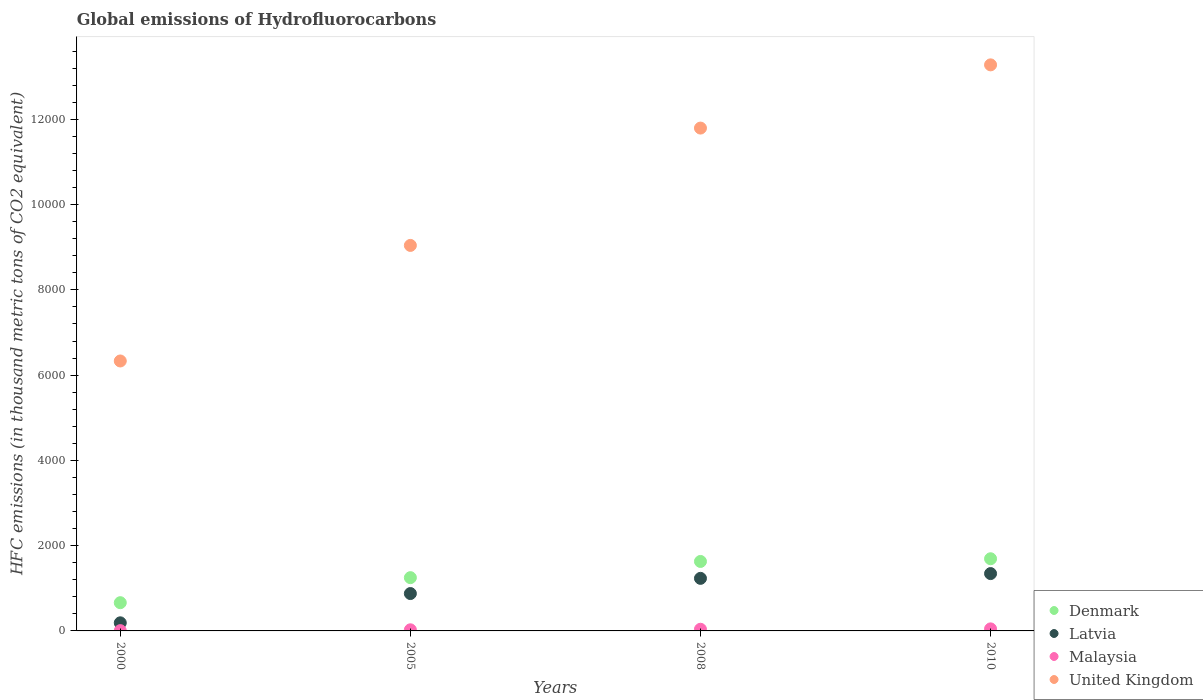How many different coloured dotlines are there?
Keep it short and to the point. 4. Is the number of dotlines equal to the number of legend labels?
Keep it short and to the point. Yes. What is the global emissions of Hydrofluorocarbons in Latvia in 2008?
Your answer should be compact. 1233.1. Across all years, what is the maximum global emissions of Hydrofluorocarbons in Malaysia?
Offer a very short reply. 48. Across all years, what is the minimum global emissions of Hydrofluorocarbons in Latvia?
Provide a succinct answer. 190. In which year was the global emissions of Hydrofluorocarbons in Denmark maximum?
Make the answer very short. 2010. What is the total global emissions of Hydrofluorocarbons in Latvia in the graph?
Your answer should be very brief. 3644.7. What is the difference between the global emissions of Hydrofluorocarbons in Malaysia in 2000 and that in 2008?
Your response must be concise. -32.3. What is the difference between the global emissions of Hydrofluorocarbons in Latvia in 2000 and the global emissions of Hydrofluorocarbons in Malaysia in 2010?
Offer a very short reply. 142. What is the average global emissions of Hydrofluorocarbons in Malaysia per year?
Provide a short and direct response. 30.05. In the year 2005, what is the difference between the global emissions of Hydrofluorocarbons in United Kingdom and global emissions of Hydrofluorocarbons in Denmark?
Ensure brevity in your answer.  7793.9. What is the ratio of the global emissions of Hydrofluorocarbons in United Kingdom in 2005 to that in 2010?
Offer a terse response. 0.68. What is the difference between the highest and the second highest global emissions of Hydrofluorocarbons in Malaysia?
Ensure brevity in your answer.  8.8. What is the difference between the highest and the lowest global emissions of Hydrofluorocarbons in United Kingdom?
Your answer should be very brief. 6946.5. Is the sum of the global emissions of Hydrofluorocarbons in United Kingdom in 2008 and 2010 greater than the maximum global emissions of Hydrofluorocarbons in Latvia across all years?
Your answer should be compact. Yes. Is it the case that in every year, the sum of the global emissions of Hydrofluorocarbons in Denmark and global emissions of Hydrofluorocarbons in Latvia  is greater than the sum of global emissions of Hydrofluorocarbons in United Kingdom and global emissions of Hydrofluorocarbons in Malaysia?
Offer a very short reply. No. Is it the case that in every year, the sum of the global emissions of Hydrofluorocarbons in Latvia and global emissions of Hydrofluorocarbons in Malaysia  is greater than the global emissions of Hydrofluorocarbons in Denmark?
Offer a very short reply. No. Is the global emissions of Hydrofluorocarbons in United Kingdom strictly greater than the global emissions of Hydrofluorocarbons in Malaysia over the years?
Keep it short and to the point. Yes. How many years are there in the graph?
Your answer should be very brief. 4. What is the difference between two consecutive major ticks on the Y-axis?
Provide a succinct answer. 2000. Does the graph contain any zero values?
Your response must be concise. No. How many legend labels are there?
Provide a succinct answer. 4. How are the legend labels stacked?
Give a very brief answer. Vertical. What is the title of the graph?
Your response must be concise. Global emissions of Hydrofluorocarbons. Does "Switzerland" appear as one of the legend labels in the graph?
Make the answer very short. No. What is the label or title of the X-axis?
Your answer should be compact. Years. What is the label or title of the Y-axis?
Your answer should be compact. HFC emissions (in thousand metric tons of CO2 equivalent). What is the HFC emissions (in thousand metric tons of CO2 equivalent) in Denmark in 2000?
Provide a short and direct response. 662.2. What is the HFC emissions (in thousand metric tons of CO2 equivalent) of Latvia in 2000?
Keep it short and to the point. 190. What is the HFC emissions (in thousand metric tons of CO2 equivalent) in United Kingdom in 2000?
Your answer should be very brief. 6332.5. What is the HFC emissions (in thousand metric tons of CO2 equivalent) of Denmark in 2005?
Offer a very short reply. 1249.5. What is the HFC emissions (in thousand metric tons of CO2 equivalent) of Latvia in 2005?
Give a very brief answer. 876.6. What is the HFC emissions (in thousand metric tons of CO2 equivalent) in Malaysia in 2005?
Make the answer very short. 26.1. What is the HFC emissions (in thousand metric tons of CO2 equivalent) in United Kingdom in 2005?
Provide a succinct answer. 9043.4. What is the HFC emissions (in thousand metric tons of CO2 equivalent) in Denmark in 2008?
Offer a terse response. 1629.6. What is the HFC emissions (in thousand metric tons of CO2 equivalent) in Latvia in 2008?
Your answer should be very brief. 1233.1. What is the HFC emissions (in thousand metric tons of CO2 equivalent) of Malaysia in 2008?
Keep it short and to the point. 39.2. What is the HFC emissions (in thousand metric tons of CO2 equivalent) of United Kingdom in 2008?
Your answer should be compact. 1.18e+04. What is the HFC emissions (in thousand metric tons of CO2 equivalent) in Denmark in 2010?
Make the answer very short. 1693. What is the HFC emissions (in thousand metric tons of CO2 equivalent) in Latvia in 2010?
Provide a succinct answer. 1345. What is the HFC emissions (in thousand metric tons of CO2 equivalent) of Malaysia in 2010?
Offer a terse response. 48. What is the HFC emissions (in thousand metric tons of CO2 equivalent) in United Kingdom in 2010?
Give a very brief answer. 1.33e+04. Across all years, what is the maximum HFC emissions (in thousand metric tons of CO2 equivalent) in Denmark?
Give a very brief answer. 1693. Across all years, what is the maximum HFC emissions (in thousand metric tons of CO2 equivalent) in Latvia?
Ensure brevity in your answer.  1345. Across all years, what is the maximum HFC emissions (in thousand metric tons of CO2 equivalent) of Malaysia?
Keep it short and to the point. 48. Across all years, what is the maximum HFC emissions (in thousand metric tons of CO2 equivalent) of United Kingdom?
Your answer should be very brief. 1.33e+04. Across all years, what is the minimum HFC emissions (in thousand metric tons of CO2 equivalent) of Denmark?
Ensure brevity in your answer.  662.2. Across all years, what is the minimum HFC emissions (in thousand metric tons of CO2 equivalent) in Latvia?
Your answer should be very brief. 190. Across all years, what is the minimum HFC emissions (in thousand metric tons of CO2 equivalent) of United Kingdom?
Your answer should be compact. 6332.5. What is the total HFC emissions (in thousand metric tons of CO2 equivalent) of Denmark in the graph?
Provide a short and direct response. 5234.3. What is the total HFC emissions (in thousand metric tons of CO2 equivalent) in Latvia in the graph?
Your answer should be very brief. 3644.7. What is the total HFC emissions (in thousand metric tons of CO2 equivalent) in Malaysia in the graph?
Your response must be concise. 120.2. What is the total HFC emissions (in thousand metric tons of CO2 equivalent) in United Kingdom in the graph?
Your response must be concise. 4.05e+04. What is the difference between the HFC emissions (in thousand metric tons of CO2 equivalent) of Denmark in 2000 and that in 2005?
Your answer should be very brief. -587.3. What is the difference between the HFC emissions (in thousand metric tons of CO2 equivalent) of Latvia in 2000 and that in 2005?
Offer a terse response. -686.6. What is the difference between the HFC emissions (in thousand metric tons of CO2 equivalent) in Malaysia in 2000 and that in 2005?
Give a very brief answer. -19.2. What is the difference between the HFC emissions (in thousand metric tons of CO2 equivalent) in United Kingdom in 2000 and that in 2005?
Your answer should be very brief. -2710.9. What is the difference between the HFC emissions (in thousand metric tons of CO2 equivalent) of Denmark in 2000 and that in 2008?
Give a very brief answer. -967.4. What is the difference between the HFC emissions (in thousand metric tons of CO2 equivalent) in Latvia in 2000 and that in 2008?
Provide a short and direct response. -1043.1. What is the difference between the HFC emissions (in thousand metric tons of CO2 equivalent) of Malaysia in 2000 and that in 2008?
Your response must be concise. -32.3. What is the difference between the HFC emissions (in thousand metric tons of CO2 equivalent) of United Kingdom in 2000 and that in 2008?
Keep it short and to the point. -5463.5. What is the difference between the HFC emissions (in thousand metric tons of CO2 equivalent) in Denmark in 2000 and that in 2010?
Your answer should be compact. -1030.8. What is the difference between the HFC emissions (in thousand metric tons of CO2 equivalent) in Latvia in 2000 and that in 2010?
Offer a very short reply. -1155. What is the difference between the HFC emissions (in thousand metric tons of CO2 equivalent) in Malaysia in 2000 and that in 2010?
Provide a short and direct response. -41.1. What is the difference between the HFC emissions (in thousand metric tons of CO2 equivalent) in United Kingdom in 2000 and that in 2010?
Your answer should be compact. -6946.5. What is the difference between the HFC emissions (in thousand metric tons of CO2 equivalent) of Denmark in 2005 and that in 2008?
Provide a short and direct response. -380.1. What is the difference between the HFC emissions (in thousand metric tons of CO2 equivalent) in Latvia in 2005 and that in 2008?
Keep it short and to the point. -356.5. What is the difference between the HFC emissions (in thousand metric tons of CO2 equivalent) in United Kingdom in 2005 and that in 2008?
Make the answer very short. -2752.6. What is the difference between the HFC emissions (in thousand metric tons of CO2 equivalent) in Denmark in 2005 and that in 2010?
Make the answer very short. -443.5. What is the difference between the HFC emissions (in thousand metric tons of CO2 equivalent) in Latvia in 2005 and that in 2010?
Offer a terse response. -468.4. What is the difference between the HFC emissions (in thousand metric tons of CO2 equivalent) in Malaysia in 2005 and that in 2010?
Your response must be concise. -21.9. What is the difference between the HFC emissions (in thousand metric tons of CO2 equivalent) of United Kingdom in 2005 and that in 2010?
Your answer should be compact. -4235.6. What is the difference between the HFC emissions (in thousand metric tons of CO2 equivalent) of Denmark in 2008 and that in 2010?
Make the answer very short. -63.4. What is the difference between the HFC emissions (in thousand metric tons of CO2 equivalent) in Latvia in 2008 and that in 2010?
Offer a terse response. -111.9. What is the difference between the HFC emissions (in thousand metric tons of CO2 equivalent) of United Kingdom in 2008 and that in 2010?
Provide a succinct answer. -1483. What is the difference between the HFC emissions (in thousand metric tons of CO2 equivalent) in Denmark in 2000 and the HFC emissions (in thousand metric tons of CO2 equivalent) in Latvia in 2005?
Offer a terse response. -214.4. What is the difference between the HFC emissions (in thousand metric tons of CO2 equivalent) in Denmark in 2000 and the HFC emissions (in thousand metric tons of CO2 equivalent) in Malaysia in 2005?
Provide a succinct answer. 636.1. What is the difference between the HFC emissions (in thousand metric tons of CO2 equivalent) in Denmark in 2000 and the HFC emissions (in thousand metric tons of CO2 equivalent) in United Kingdom in 2005?
Your response must be concise. -8381.2. What is the difference between the HFC emissions (in thousand metric tons of CO2 equivalent) in Latvia in 2000 and the HFC emissions (in thousand metric tons of CO2 equivalent) in Malaysia in 2005?
Your answer should be compact. 163.9. What is the difference between the HFC emissions (in thousand metric tons of CO2 equivalent) of Latvia in 2000 and the HFC emissions (in thousand metric tons of CO2 equivalent) of United Kingdom in 2005?
Your response must be concise. -8853.4. What is the difference between the HFC emissions (in thousand metric tons of CO2 equivalent) in Malaysia in 2000 and the HFC emissions (in thousand metric tons of CO2 equivalent) in United Kingdom in 2005?
Offer a terse response. -9036.5. What is the difference between the HFC emissions (in thousand metric tons of CO2 equivalent) of Denmark in 2000 and the HFC emissions (in thousand metric tons of CO2 equivalent) of Latvia in 2008?
Keep it short and to the point. -570.9. What is the difference between the HFC emissions (in thousand metric tons of CO2 equivalent) in Denmark in 2000 and the HFC emissions (in thousand metric tons of CO2 equivalent) in Malaysia in 2008?
Your response must be concise. 623. What is the difference between the HFC emissions (in thousand metric tons of CO2 equivalent) in Denmark in 2000 and the HFC emissions (in thousand metric tons of CO2 equivalent) in United Kingdom in 2008?
Keep it short and to the point. -1.11e+04. What is the difference between the HFC emissions (in thousand metric tons of CO2 equivalent) of Latvia in 2000 and the HFC emissions (in thousand metric tons of CO2 equivalent) of Malaysia in 2008?
Your response must be concise. 150.8. What is the difference between the HFC emissions (in thousand metric tons of CO2 equivalent) of Latvia in 2000 and the HFC emissions (in thousand metric tons of CO2 equivalent) of United Kingdom in 2008?
Your answer should be compact. -1.16e+04. What is the difference between the HFC emissions (in thousand metric tons of CO2 equivalent) in Malaysia in 2000 and the HFC emissions (in thousand metric tons of CO2 equivalent) in United Kingdom in 2008?
Your response must be concise. -1.18e+04. What is the difference between the HFC emissions (in thousand metric tons of CO2 equivalent) of Denmark in 2000 and the HFC emissions (in thousand metric tons of CO2 equivalent) of Latvia in 2010?
Provide a succinct answer. -682.8. What is the difference between the HFC emissions (in thousand metric tons of CO2 equivalent) in Denmark in 2000 and the HFC emissions (in thousand metric tons of CO2 equivalent) in Malaysia in 2010?
Your answer should be very brief. 614.2. What is the difference between the HFC emissions (in thousand metric tons of CO2 equivalent) in Denmark in 2000 and the HFC emissions (in thousand metric tons of CO2 equivalent) in United Kingdom in 2010?
Your answer should be very brief. -1.26e+04. What is the difference between the HFC emissions (in thousand metric tons of CO2 equivalent) of Latvia in 2000 and the HFC emissions (in thousand metric tons of CO2 equivalent) of Malaysia in 2010?
Provide a succinct answer. 142. What is the difference between the HFC emissions (in thousand metric tons of CO2 equivalent) in Latvia in 2000 and the HFC emissions (in thousand metric tons of CO2 equivalent) in United Kingdom in 2010?
Offer a very short reply. -1.31e+04. What is the difference between the HFC emissions (in thousand metric tons of CO2 equivalent) in Malaysia in 2000 and the HFC emissions (in thousand metric tons of CO2 equivalent) in United Kingdom in 2010?
Provide a short and direct response. -1.33e+04. What is the difference between the HFC emissions (in thousand metric tons of CO2 equivalent) of Denmark in 2005 and the HFC emissions (in thousand metric tons of CO2 equivalent) of Latvia in 2008?
Offer a very short reply. 16.4. What is the difference between the HFC emissions (in thousand metric tons of CO2 equivalent) in Denmark in 2005 and the HFC emissions (in thousand metric tons of CO2 equivalent) in Malaysia in 2008?
Your response must be concise. 1210.3. What is the difference between the HFC emissions (in thousand metric tons of CO2 equivalent) of Denmark in 2005 and the HFC emissions (in thousand metric tons of CO2 equivalent) of United Kingdom in 2008?
Make the answer very short. -1.05e+04. What is the difference between the HFC emissions (in thousand metric tons of CO2 equivalent) of Latvia in 2005 and the HFC emissions (in thousand metric tons of CO2 equivalent) of Malaysia in 2008?
Offer a terse response. 837.4. What is the difference between the HFC emissions (in thousand metric tons of CO2 equivalent) of Latvia in 2005 and the HFC emissions (in thousand metric tons of CO2 equivalent) of United Kingdom in 2008?
Your response must be concise. -1.09e+04. What is the difference between the HFC emissions (in thousand metric tons of CO2 equivalent) in Malaysia in 2005 and the HFC emissions (in thousand metric tons of CO2 equivalent) in United Kingdom in 2008?
Keep it short and to the point. -1.18e+04. What is the difference between the HFC emissions (in thousand metric tons of CO2 equivalent) in Denmark in 2005 and the HFC emissions (in thousand metric tons of CO2 equivalent) in Latvia in 2010?
Offer a very short reply. -95.5. What is the difference between the HFC emissions (in thousand metric tons of CO2 equivalent) of Denmark in 2005 and the HFC emissions (in thousand metric tons of CO2 equivalent) of Malaysia in 2010?
Your answer should be very brief. 1201.5. What is the difference between the HFC emissions (in thousand metric tons of CO2 equivalent) of Denmark in 2005 and the HFC emissions (in thousand metric tons of CO2 equivalent) of United Kingdom in 2010?
Give a very brief answer. -1.20e+04. What is the difference between the HFC emissions (in thousand metric tons of CO2 equivalent) of Latvia in 2005 and the HFC emissions (in thousand metric tons of CO2 equivalent) of Malaysia in 2010?
Your response must be concise. 828.6. What is the difference between the HFC emissions (in thousand metric tons of CO2 equivalent) of Latvia in 2005 and the HFC emissions (in thousand metric tons of CO2 equivalent) of United Kingdom in 2010?
Your response must be concise. -1.24e+04. What is the difference between the HFC emissions (in thousand metric tons of CO2 equivalent) of Malaysia in 2005 and the HFC emissions (in thousand metric tons of CO2 equivalent) of United Kingdom in 2010?
Offer a terse response. -1.33e+04. What is the difference between the HFC emissions (in thousand metric tons of CO2 equivalent) of Denmark in 2008 and the HFC emissions (in thousand metric tons of CO2 equivalent) of Latvia in 2010?
Your answer should be very brief. 284.6. What is the difference between the HFC emissions (in thousand metric tons of CO2 equivalent) in Denmark in 2008 and the HFC emissions (in thousand metric tons of CO2 equivalent) in Malaysia in 2010?
Your answer should be very brief. 1581.6. What is the difference between the HFC emissions (in thousand metric tons of CO2 equivalent) in Denmark in 2008 and the HFC emissions (in thousand metric tons of CO2 equivalent) in United Kingdom in 2010?
Provide a short and direct response. -1.16e+04. What is the difference between the HFC emissions (in thousand metric tons of CO2 equivalent) of Latvia in 2008 and the HFC emissions (in thousand metric tons of CO2 equivalent) of Malaysia in 2010?
Your answer should be compact. 1185.1. What is the difference between the HFC emissions (in thousand metric tons of CO2 equivalent) in Latvia in 2008 and the HFC emissions (in thousand metric tons of CO2 equivalent) in United Kingdom in 2010?
Your answer should be compact. -1.20e+04. What is the difference between the HFC emissions (in thousand metric tons of CO2 equivalent) of Malaysia in 2008 and the HFC emissions (in thousand metric tons of CO2 equivalent) of United Kingdom in 2010?
Keep it short and to the point. -1.32e+04. What is the average HFC emissions (in thousand metric tons of CO2 equivalent) in Denmark per year?
Your answer should be very brief. 1308.58. What is the average HFC emissions (in thousand metric tons of CO2 equivalent) in Latvia per year?
Provide a short and direct response. 911.17. What is the average HFC emissions (in thousand metric tons of CO2 equivalent) in Malaysia per year?
Provide a short and direct response. 30.05. What is the average HFC emissions (in thousand metric tons of CO2 equivalent) in United Kingdom per year?
Provide a short and direct response. 1.01e+04. In the year 2000, what is the difference between the HFC emissions (in thousand metric tons of CO2 equivalent) in Denmark and HFC emissions (in thousand metric tons of CO2 equivalent) in Latvia?
Provide a succinct answer. 472.2. In the year 2000, what is the difference between the HFC emissions (in thousand metric tons of CO2 equivalent) in Denmark and HFC emissions (in thousand metric tons of CO2 equivalent) in Malaysia?
Your answer should be very brief. 655.3. In the year 2000, what is the difference between the HFC emissions (in thousand metric tons of CO2 equivalent) in Denmark and HFC emissions (in thousand metric tons of CO2 equivalent) in United Kingdom?
Provide a succinct answer. -5670.3. In the year 2000, what is the difference between the HFC emissions (in thousand metric tons of CO2 equivalent) in Latvia and HFC emissions (in thousand metric tons of CO2 equivalent) in Malaysia?
Your answer should be compact. 183.1. In the year 2000, what is the difference between the HFC emissions (in thousand metric tons of CO2 equivalent) in Latvia and HFC emissions (in thousand metric tons of CO2 equivalent) in United Kingdom?
Your answer should be compact. -6142.5. In the year 2000, what is the difference between the HFC emissions (in thousand metric tons of CO2 equivalent) in Malaysia and HFC emissions (in thousand metric tons of CO2 equivalent) in United Kingdom?
Your response must be concise. -6325.6. In the year 2005, what is the difference between the HFC emissions (in thousand metric tons of CO2 equivalent) in Denmark and HFC emissions (in thousand metric tons of CO2 equivalent) in Latvia?
Offer a terse response. 372.9. In the year 2005, what is the difference between the HFC emissions (in thousand metric tons of CO2 equivalent) in Denmark and HFC emissions (in thousand metric tons of CO2 equivalent) in Malaysia?
Offer a terse response. 1223.4. In the year 2005, what is the difference between the HFC emissions (in thousand metric tons of CO2 equivalent) of Denmark and HFC emissions (in thousand metric tons of CO2 equivalent) of United Kingdom?
Provide a succinct answer. -7793.9. In the year 2005, what is the difference between the HFC emissions (in thousand metric tons of CO2 equivalent) of Latvia and HFC emissions (in thousand metric tons of CO2 equivalent) of Malaysia?
Offer a very short reply. 850.5. In the year 2005, what is the difference between the HFC emissions (in thousand metric tons of CO2 equivalent) of Latvia and HFC emissions (in thousand metric tons of CO2 equivalent) of United Kingdom?
Ensure brevity in your answer.  -8166.8. In the year 2005, what is the difference between the HFC emissions (in thousand metric tons of CO2 equivalent) in Malaysia and HFC emissions (in thousand metric tons of CO2 equivalent) in United Kingdom?
Ensure brevity in your answer.  -9017.3. In the year 2008, what is the difference between the HFC emissions (in thousand metric tons of CO2 equivalent) in Denmark and HFC emissions (in thousand metric tons of CO2 equivalent) in Latvia?
Your response must be concise. 396.5. In the year 2008, what is the difference between the HFC emissions (in thousand metric tons of CO2 equivalent) in Denmark and HFC emissions (in thousand metric tons of CO2 equivalent) in Malaysia?
Offer a terse response. 1590.4. In the year 2008, what is the difference between the HFC emissions (in thousand metric tons of CO2 equivalent) of Denmark and HFC emissions (in thousand metric tons of CO2 equivalent) of United Kingdom?
Offer a very short reply. -1.02e+04. In the year 2008, what is the difference between the HFC emissions (in thousand metric tons of CO2 equivalent) of Latvia and HFC emissions (in thousand metric tons of CO2 equivalent) of Malaysia?
Keep it short and to the point. 1193.9. In the year 2008, what is the difference between the HFC emissions (in thousand metric tons of CO2 equivalent) in Latvia and HFC emissions (in thousand metric tons of CO2 equivalent) in United Kingdom?
Keep it short and to the point. -1.06e+04. In the year 2008, what is the difference between the HFC emissions (in thousand metric tons of CO2 equivalent) of Malaysia and HFC emissions (in thousand metric tons of CO2 equivalent) of United Kingdom?
Ensure brevity in your answer.  -1.18e+04. In the year 2010, what is the difference between the HFC emissions (in thousand metric tons of CO2 equivalent) of Denmark and HFC emissions (in thousand metric tons of CO2 equivalent) of Latvia?
Give a very brief answer. 348. In the year 2010, what is the difference between the HFC emissions (in thousand metric tons of CO2 equivalent) of Denmark and HFC emissions (in thousand metric tons of CO2 equivalent) of Malaysia?
Provide a succinct answer. 1645. In the year 2010, what is the difference between the HFC emissions (in thousand metric tons of CO2 equivalent) of Denmark and HFC emissions (in thousand metric tons of CO2 equivalent) of United Kingdom?
Provide a short and direct response. -1.16e+04. In the year 2010, what is the difference between the HFC emissions (in thousand metric tons of CO2 equivalent) in Latvia and HFC emissions (in thousand metric tons of CO2 equivalent) in Malaysia?
Offer a terse response. 1297. In the year 2010, what is the difference between the HFC emissions (in thousand metric tons of CO2 equivalent) in Latvia and HFC emissions (in thousand metric tons of CO2 equivalent) in United Kingdom?
Your answer should be compact. -1.19e+04. In the year 2010, what is the difference between the HFC emissions (in thousand metric tons of CO2 equivalent) in Malaysia and HFC emissions (in thousand metric tons of CO2 equivalent) in United Kingdom?
Provide a succinct answer. -1.32e+04. What is the ratio of the HFC emissions (in thousand metric tons of CO2 equivalent) of Denmark in 2000 to that in 2005?
Make the answer very short. 0.53. What is the ratio of the HFC emissions (in thousand metric tons of CO2 equivalent) in Latvia in 2000 to that in 2005?
Provide a short and direct response. 0.22. What is the ratio of the HFC emissions (in thousand metric tons of CO2 equivalent) in Malaysia in 2000 to that in 2005?
Provide a short and direct response. 0.26. What is the ratio of the HFC emissions (in thousand metric tons of CO2 equivalent) in United Kingdom in 2000 to that in 2005?
Your answer should be very brief. 0.7. What is the ratio of the HFC emissions (in thousand metric tons of CO2 equivalent) of Denmark in 2000 to that in 2008?
Offer a terse response. 0.41. What is the ratio of the HFC emissions (in thousand metric tons of CO2 equivalent) in Latvia in 2000 to that in 2008?
Ensure brevity in your answer.  0.15. What is the ratio of the HFC emissions (in thousand metric tons of CO2 equivalent) of Malaysia in 2000 to that in 2008?
Provide a succinct answer. 0.18. What is the ratio of the HFC emissions (in thousand metric tons of CO2 equivalent) of United Kingdom in 2000 to that in 2008?
Ensure brevity in your answer.  0.54. What is the ratio of the HFC emissions (in thousand metric tons of CO2 equivalent) in Denmark in 2000 to that in 2010?
Make the answer very short. 0.39. What is the ratio of the HFC emissions (in thousand metric tons of CO2 equivalent) of Latvia in 2000 to that in 2010?
Make the answer very short. 0.14. What is the ratio of the HFC emissions (in thousand metric tons of CO2 equivalent) of Malaysia in 2000 to that in 2010?
Offer a very short reply. 0.14. What is the ratio of the HFC emissions (in thousand metric tons of CO2 equivalent) of United Kingdom in 2000 to that in 2010?
Offer a terse response. 0.48. What is the ratio of the HFC emissions (in thousand metric tons of CO2 equivalent) in Denmark in 2005 to that in 2008?
Provide a short and direct response. 0.77. What is the ratio of the HFC emissions (in thousand metric tons of CO2 equivalent) in Latvia in 2005 to that in 2008?
Offer a terse response. 0.71. What is the ratio of the HFC emissions (in thousand metric tons of CO2 equivalent) in Malaysia in 2005 to that in 2008?
Make the answer very short. 0.67. What is the ratio of the HFC emissions (in thousand metric tons of CO2 equivalent) in United Kingdom in 2005 to that in 2008?
Your response must be concise. 0.77. What is the ratio of the HFC emissions (in thousand metric tons of CO2 equivalent) in Denmark in 2005 to that in 2010?
Offer a terse response. 0.74. What is the ratio of the HFC emissions (in thousand metric tons of CO2 equivalent) in Latvia in 2005 to that in 2010?
Your response must be concise. 0.65. What is the ratio of the HFC emissions (in thousand metric tons of CO2 equivalent) in Malaysia in 2005 to that in 2010?
Provide a short and direct response. 0.54. What is the ratio of the HFC emissions (in thousand metric tons of CO2 equivalent) in United Kingdom in 2005 to that in 2010?
Your response must be concise. 0.68. What is the ratio of the HFC emissions (in thousand metric tons of CO2 equivalent) of Denmark in 2008 to that in 2010?
Your response must be concise. 0.96. What is the ratio of the HFC emissions (in thousand metric tons of CO2 equivalent) of Latvia in 2008 to that in 2010?
Your answer should be very brief. 0.92. What is the ratio of the HFC emissions (in thousand metric tons of CO2 equivalent) in Malaysia in 2008 to that in 2010?
Provide a short and direct response. 0.82. What is the ratio of the HFC emissions (in thousand metric tons of CO2 equivalent) in United Kingdom in 2008 to that in 2010?
Ensure brevity in your answer.  0.89. What is the difference between the highest and the second highest HFC emissions (in thousand metric tons of CO2 equivalent) in Denmark?
Your answer should be compact. 63.4. What is the difference between the highest and the second highest HFC emissions (in thousand metric tons of CO2 equivalent) of Latvia?
Give a very brief answer. 111.9. What is the difference between the highest and the second highest HFC emissions (in thousand metric tons of CO2 equivalent) in United Kingdom?
Keep it short and to the point. 1483. What is the difference between the highest and the lowest HFC emissions (in thousand metric tons of CO2 equivalent) of Denmark?
Offer a very short reply. 1030.8. What is the difference between the highest and the lowest HFC emissions (in thousand metric tons of CO2 equivalent) of Latvia?
Your response must be concise. 1155. What is the difference between the highest and the lowest HFC emissions (in thousand metric tons of CO2 equivalent) in Malaysia?
Offer a very short reply. 41.1. What is the difference between the highest and the lowest HFC emissions (in thousand metric tons of CO2 equivalent) in United Kingdom?
Your answer should be compact. 6946.5. 